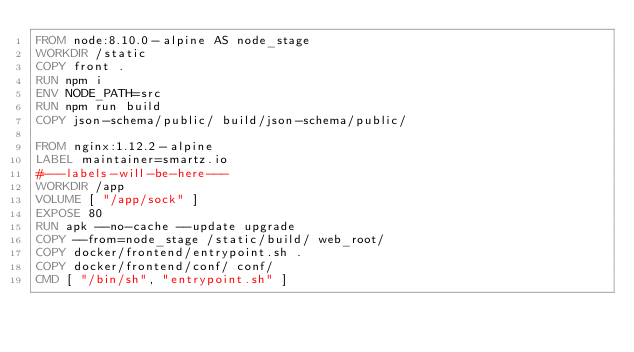Convert code to text. <code><loc_0><loc_0><loc_500><loc_500><_Dockerfile_>FROM node:8.10.0-alpine AS node_stage
WORKDIR /static
COPY front .
RUN npm i
ENV NODE_PATH=src
RUN npm run build
COPY json-schema/public/ build/json-schema/public/

FROM nginx:1.12.2-alpine
LABEL maintainer=smartz.io
#---labels-will-be-here---
WORKDIR /app
VOLUME [ "/app/sock" ]
EXPOSE 80
RUN apk --no-cache --update upgrade
COPY --from=node_stage /static/build/ web_root/
COPY docker/frontend/entrypoint.sh .
COPY docker/frontend/conf/ conf/
CMD [ "/bin/sh", "entrypoint.sh" ]
</code> 